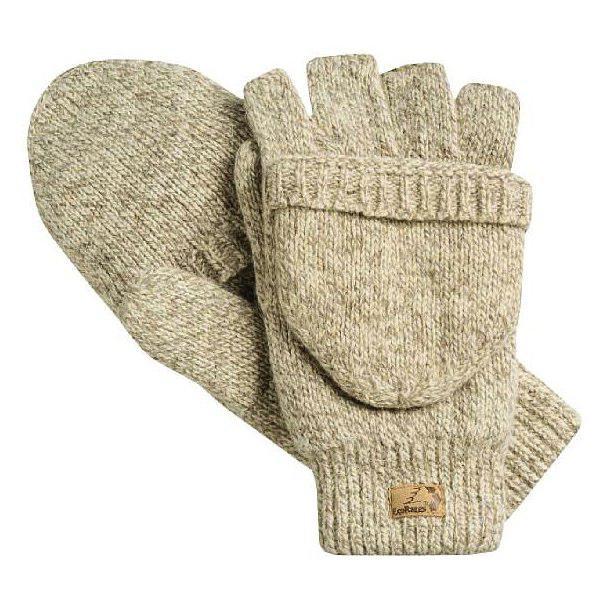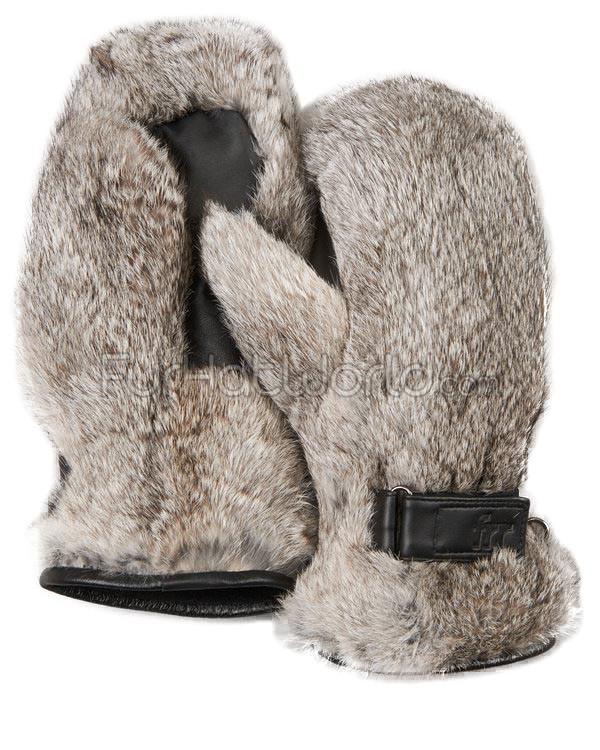The first image is the image on the left, the second image is the image on the right. Analyze the images presented: Is the assertion "A closed round mitten is faced palms down with the thumb part on the left side." valid? Answer yes or no. Yes. 